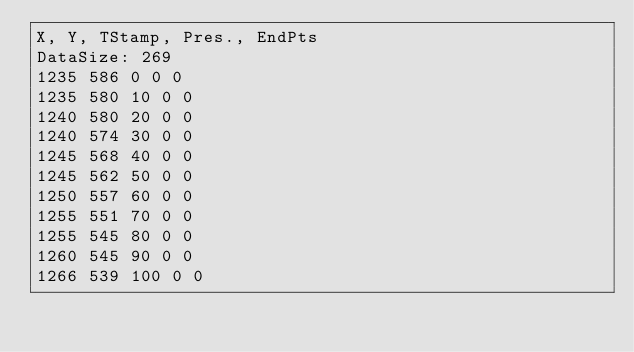<code> <loc_0><loc_0><loc_500><loc_500><_SML_>X, Y, TStamp, Pres., EndPts
DataSize: 269
1235 586 0 0 0
1235 580 10 0 0
1240 580 20 0 0
1240 574 30 0 0
1245 568 40 0 0
1245 562 50 0 0
1250 557 60 0 0
1255 551 70 0 0
1255 545 80 0 0
1260 545 90 0 0
1266 539 100 0 0</code> 